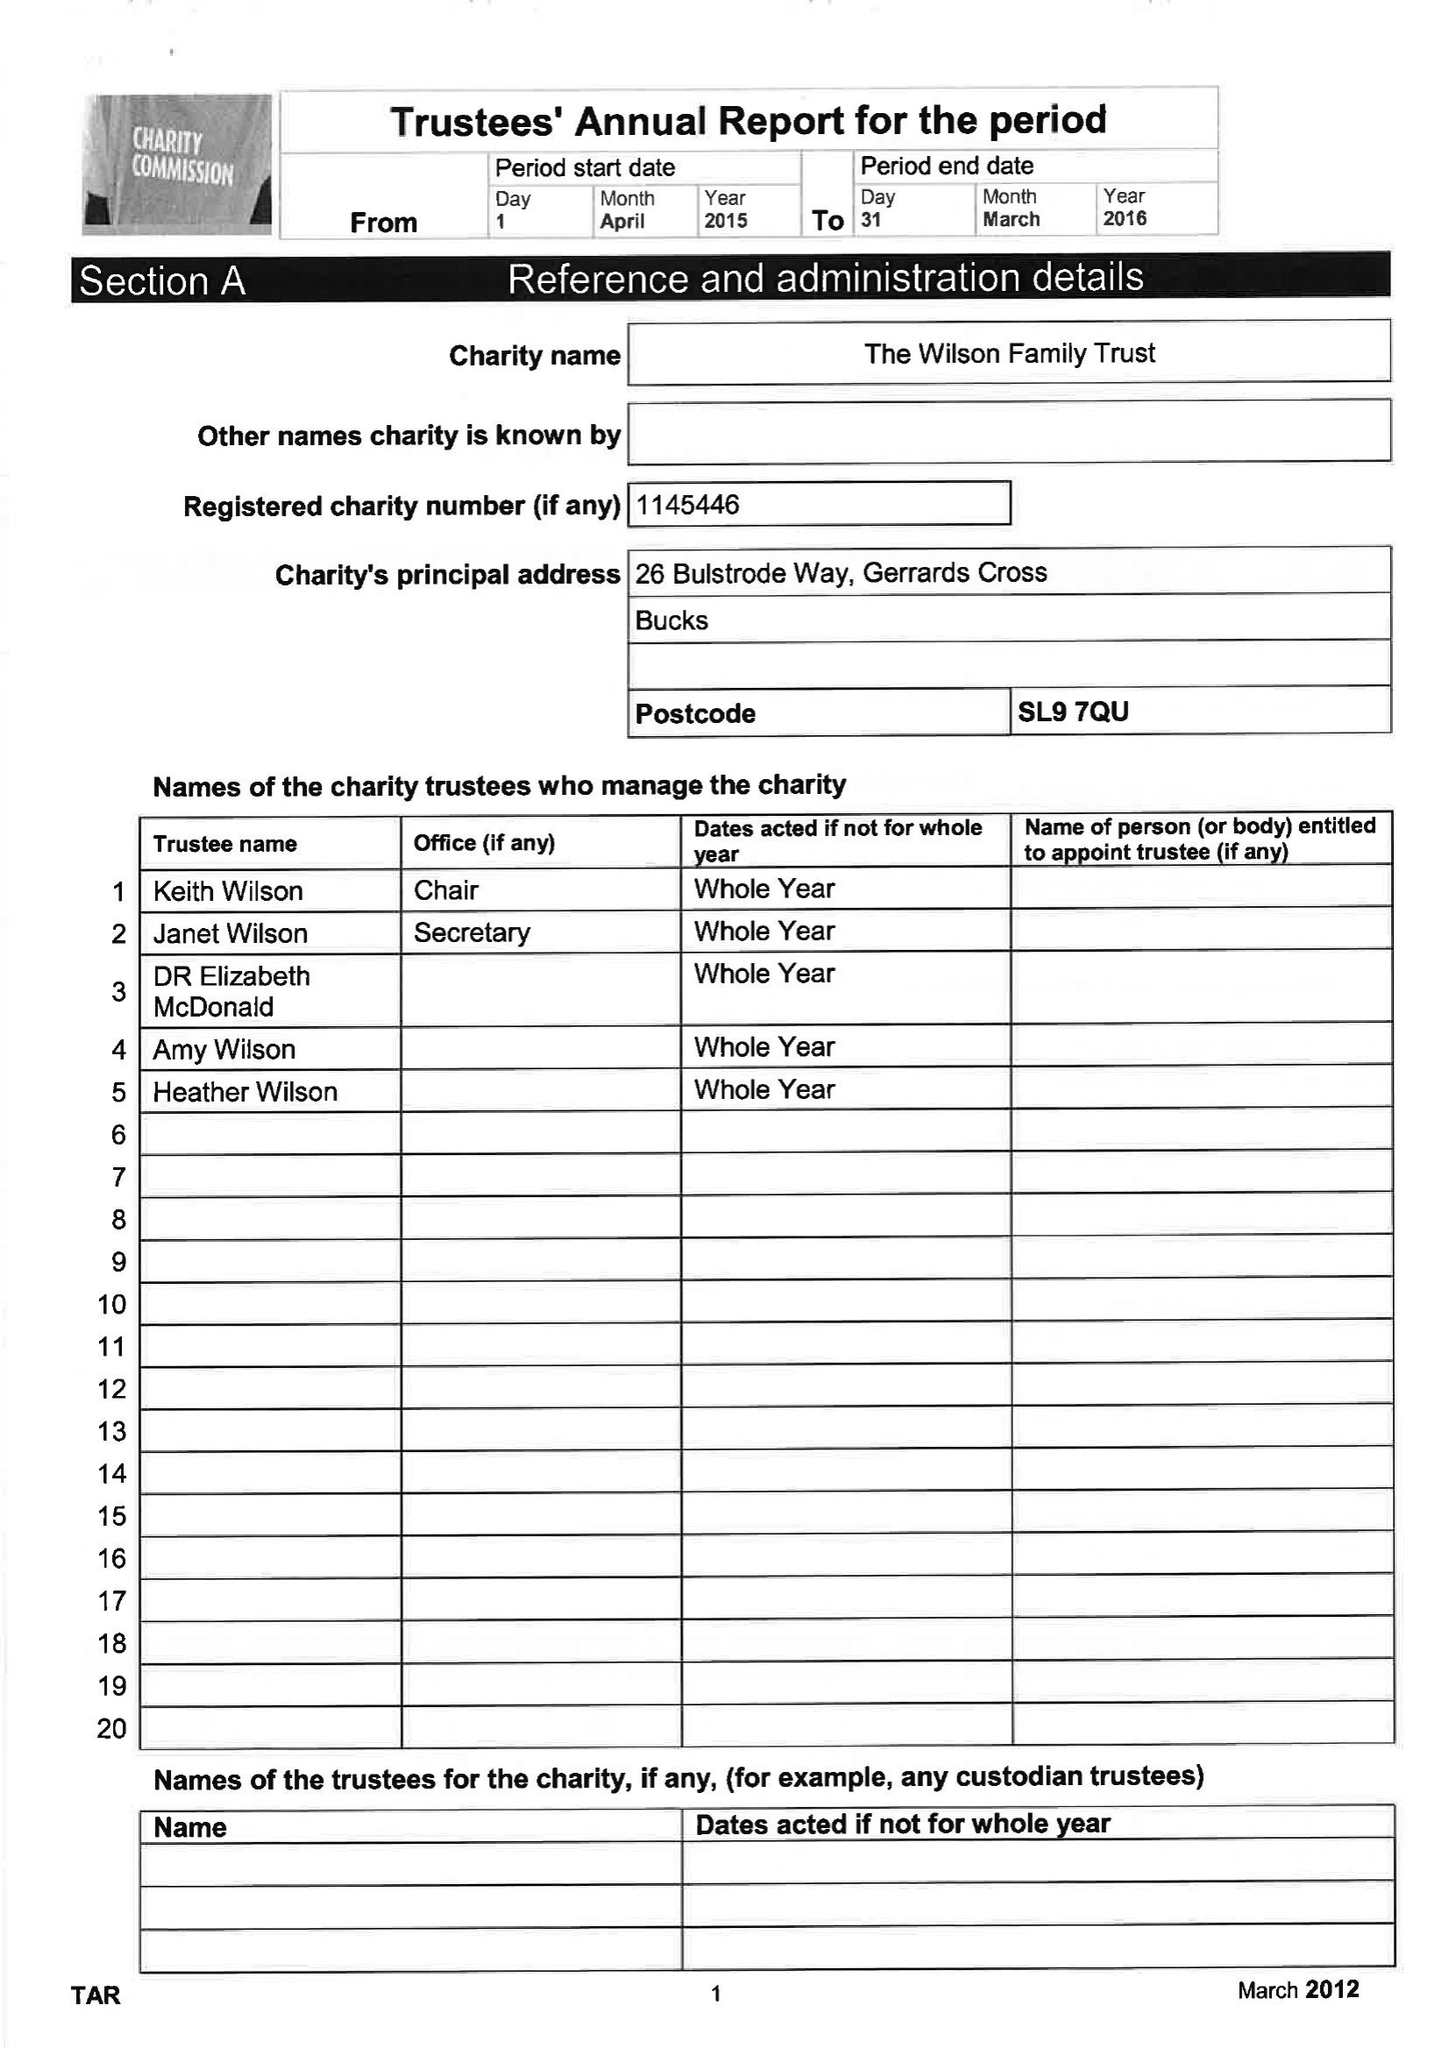What is the value for the charity_name?
Answer the question using a single word or phrase. The Wilson Family Trust 